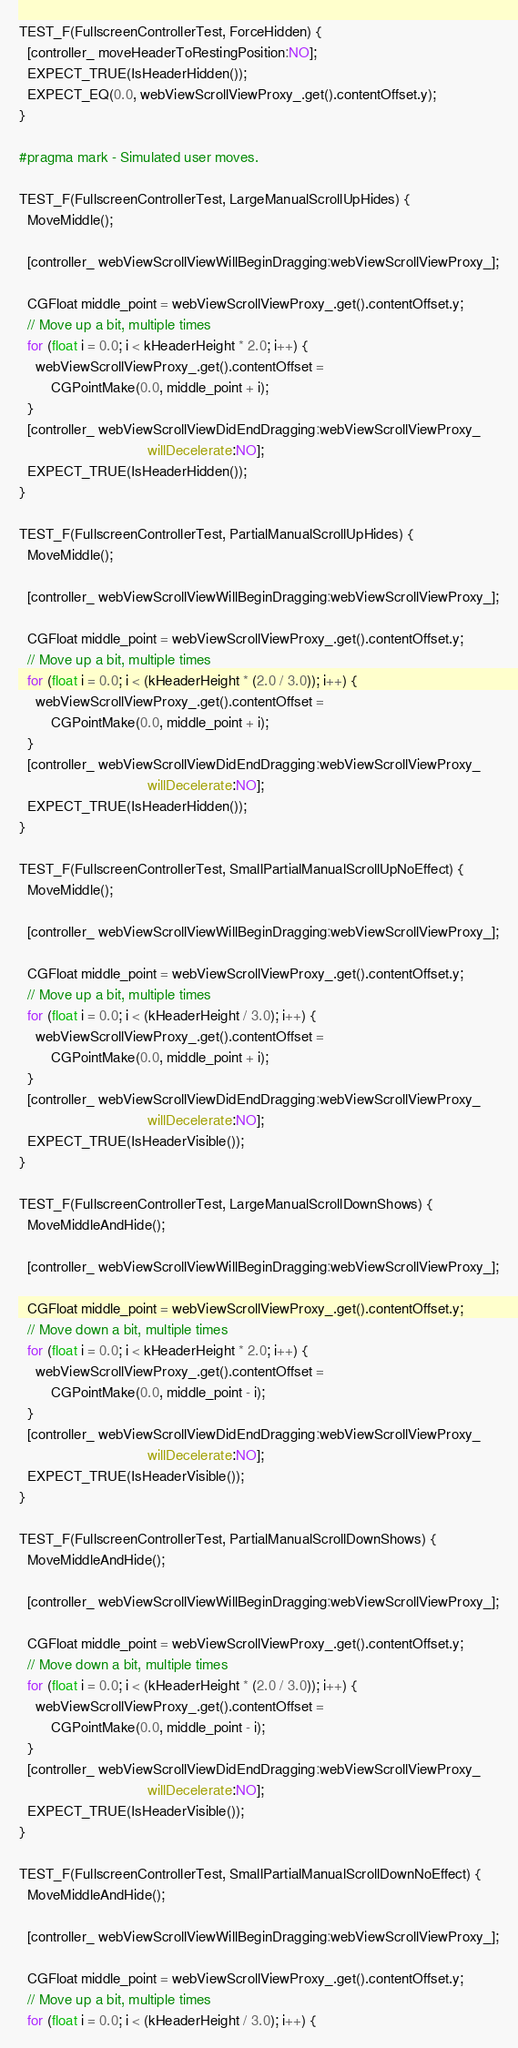<code> <loc_0><loc_0><loc_500><loc_500><_ObjectiveC_>
TEST_F(FullscreenControllerTest, ForceHidden) {
  [controller_ moveHeaderToRestingPosition:NO];
  EXPECT_TRUE(IsHeaderHidden());
  EXPECT_EQ(0.0, webViewScrollViewProxy_.get().contentOffset.y);
}

#pragma mark - Simulated user moves.

TEST_F(FullscreenControllerTest, LargeManualScrollUpHides) {
  MoveMiddle();

  [controller_ webViewScrollViewWillBeginDragging:webViewScrollViewProxy_];

  CGFloat middle_point = webViewScrollViewProxy_.get().contentOffset.y;
  // Move up a bit, multiple times
  for (float i = 0.0; i < kHeaderHeight * 2.0; i++) {
    webViewScrollViewProxy_.get().contentOffset =
        CGPointMake(0.0, middle_point + i);
  }
  [controller_ webViewScrollViewDidEndDragging:webViewScrollViewProxy_
                                willDecelerate:NO];
  EXPECT_TRUE(IsHeaderHidden());
}

TEST_F(FullscreenControllerTest, PartialManualScrollUpHides) {
  MoveMiddle();

  [controller_ webViewScrollViewWillBeginDragging:webViewScrollViewProxy_];

  CGFloat middle_point = webViewScrollViewProxy_.get().contentOffset.y;
  // Move up a bit, multiple times
  for (float i = 0.0; i < (kHeaderHeight * (2.0 / 3.0)); i++) {
    webViewScrollViewProxy_.get().contentOffset =
        CGPointMake(0.0, middle_point + i);
  }
  [controller_ webViewScrollViewDidEndDragging:webViewScrollViewProxy_
                                willDecelerate:NO];
  EXPECT_TRUE(IsHeaderHidden());
}

TEST_F(FullscreenControllerTest, SmallPartialManualScrollUpNoEffect) {
  MoveMiddle();

  [controller_ webViewScrollViewWillBeginDragging:webViewScrollViewProxy_];

  CGFloat middle_point = webViewScrollViewProxy_.get().contentOffset.y;
  // Move up a bit, multiple times
  for (float i = 0.0; i < (kHeaderHeight / 3.0); i++) {
    webViewScrollViewProxy_.get().contentOffset =
        CGPointMake(0.0, middle_point + i);
  }
  [controller_ webViewScrollViewDidEndDragging:webViewScrollViewProxy_
                                willDecelerate:NO];
  EXPECT_TRUE(IsHeaderVisible());
}

TEST_F(FullscreenControllerTest, LargeManualScrollDownShows) {
  MoveMiddleAndHide();

  [controller_ webViewScrollViewWillBeginDragging:webViewScrollViewProxy_];

  CGFloat middle_point = webViewScrollViewProxy_.get().contentOffset.y;
  // Move down a bit, multiple times
  for (float i = 0.0; i < kHeaderHeight * 2.0; i++) {
    webViewScrollViewProxy_.get().contentOffset =
        CGPointMake(0.0, middle_point - i);
  }
  [controller_ webViewScrollViewDidEndDragging:webViewScrollViewProxy_
                                willDecelerate:NO];
  EXPECT_TRUE(IsHeaderVisible());
}

TEST_F(FullscreenControllerTest, PartialManualScrollDownShows) {
  MoveMiddleAndHide();

  [controller_ webViewScrollViewWillBeginDragging:webViewScrollViewProxy_];

  CGFloat middle_point = webViewScrollViewProxy_.get().contentOffset.y;
  // Move down a bit, multiple times
  for (float i = 0.0; i < (kHeaderHeight * (2.0 / 3.0)); i++) {
    webViewScrollViewProxy_.get().contentOffset =
        CGPointMake(0.0, middle_point - i);
  }
  [controller_ webViewScrollViewDidEndDragging:webViewScrollViewProxy_
                                willDecelerate:NO];
  EXPECT_TRUE(IsHeaderVisible());
}

TEST_F(FullscreenControllerTest, SmallPartialManualScrollDownNoEffect) {
  MoveMiddleAndHide();

  [controller_ webViewScrollViewWillBeginDragging:webViewScrollViewProxy_];

  CGFloat middle_point = webViewScrollViewProxy_.get().contentOffset.y;
  // Move up a bit, multiple times
  for (float i = 0.0; i < (kHeaderHeight / 3.0); i++) {</code> 